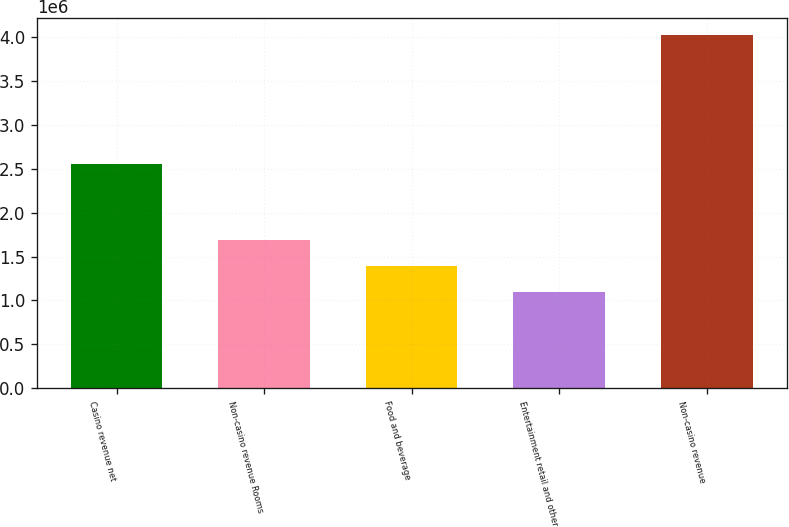Convert chart. <chart><loc_0><loc_0><loc_500><loc_500><bar_chart><fcel>Casino revenue net<fcel>Non-casino revenue Rooms<fcel>Food and beverage<fcel>Entertainment retail and other<fcel>Non-casino revenue<nl><fcel>2.55367e+06<fcel>1.68564e+06<fcel>1.39314e+06<fcel>1.09722e+06<fcel>4.02219e+06<nl></chart> 